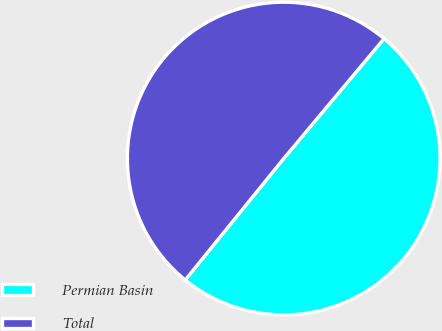Convert chart to OTSL. <chart><loc_0><loc_0><loc_500><loc_500><pie_chart><fcel>Permian Basin<fcel>Total<nl><fcel>49.76%<fcel>50.24%<nl></chart> 